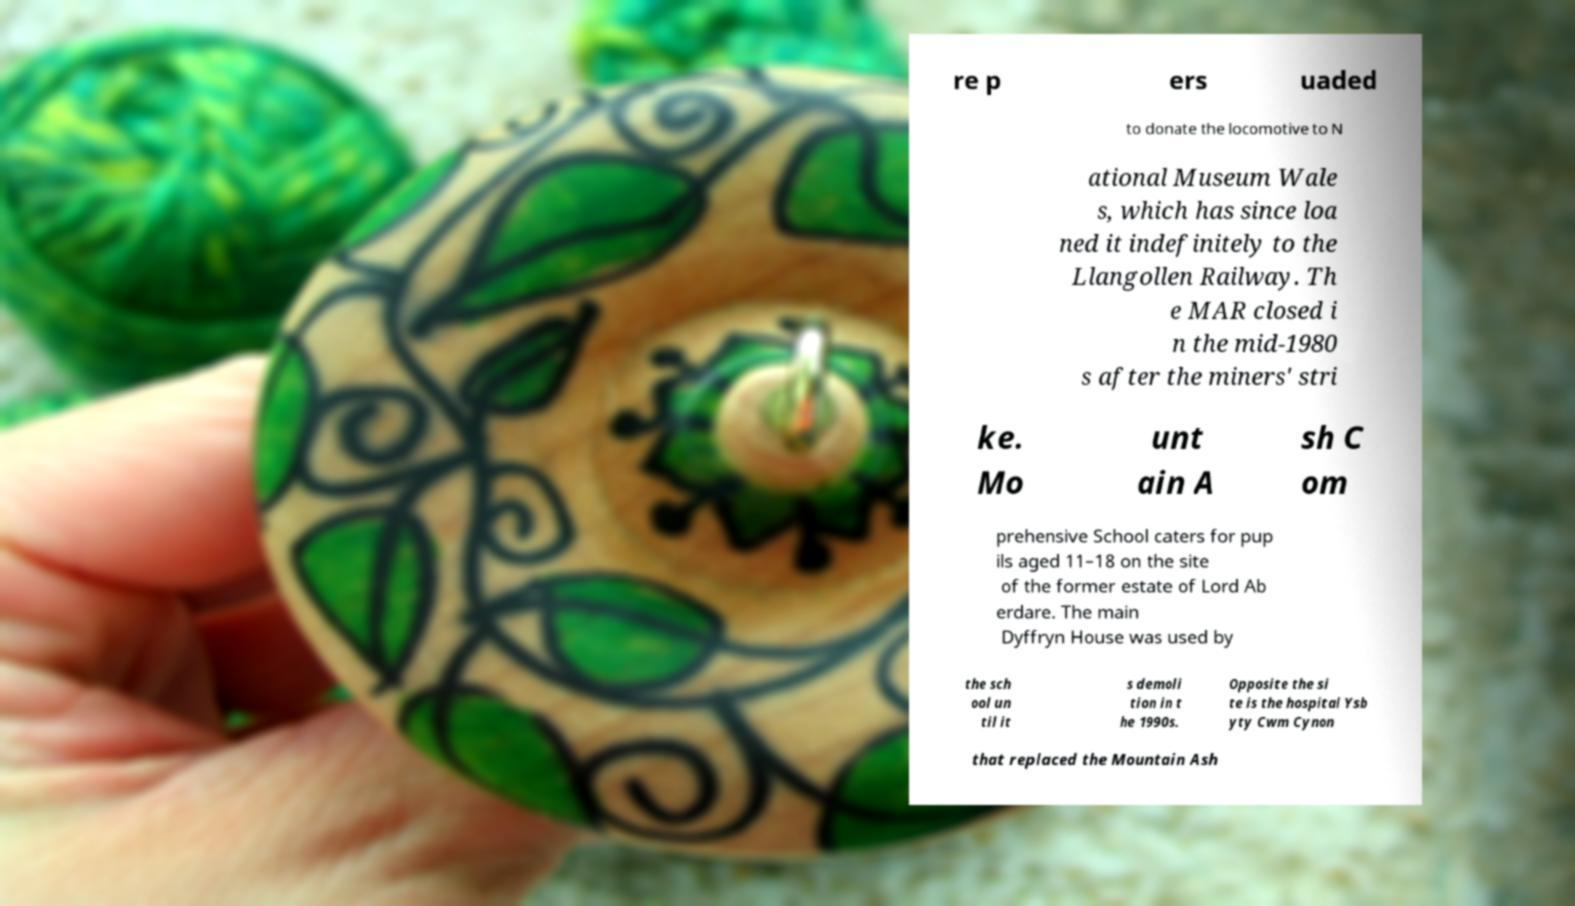Can you read and provide the text displayed in the image?This photo seems to have some interesting text. Can you extract and type it out for me? re p ers uaded to donate the locomotive to N ational Museum Wale s, which has since loa ned it indefinitely to the Llangollen Railway. Th e MAR closed i n the mid-1980 s after the miners' stri ke. Mo unt ain A sh C om prehensive School caters for pup ils aged 11–18 on the site of the former estate of Lord Ab erdare. The main Dyffryn House was used by the sch ool un til it s demoli tion in t he 1990s. Opposite the si te is the hospital Ysb yty Cwm Cynon that replaced the Mountain Ash 